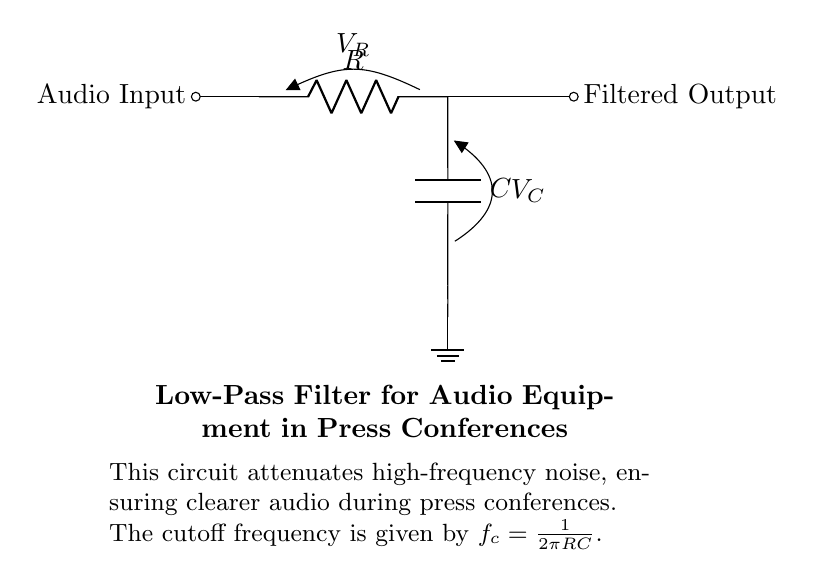What components are in the circuit? The circuit contains a resistor and a capacitor, which are the fundamental components of a low-pass filter. There is also an audio input and a filtered output indicated in the diagram.
Answer: Resistor and Capacitor What is the function of the resistor in this circuit? The resistor limits the current flow in the circuit, which affects the voltage drop across it and helps determine the overall behavior of the filter. In this configuration, it collaborates with the capacitor to set the cutoff frequency.
Answer: Limit current flow What is the cutoff frequency formula for this low-pass filter? The cutoff frequency of the low-pass filter is defined by the relationship between the resistor (R) and capacitor (C) values. According to the circuit diagram, the formula is given as f_c = 1/(2πRC).
Answer: f_c = 1/(2πRC) How does increasing the capacitance affect the cutoff frequency? Increasing capacitance (C) will decrease the cutoff frequency (f_c), as per the formula. A lower cutoff frequency means that the filter allows fewer high-frequency signals to pass, which is desirable for clearer audio.
Answer: Decreases cutoff frequency What happens to high-frequency noise when using this filter? The circuit is designed to attenuate or reduce high-frequency noise, which ensures that only low frequencies are allowed through to the output. This results in clearer audio during press conferences.
Answer: Attenuates high-frequency noise What is the relationship between resistor value and audio output quality? A higher resistor value increases the time constant of the RC circuit, which can lead to slower responses and may result in a less sharp cutoff at the desired frequency. This can adversely affect audio clarity, particularly with transients.
Answer: Affects audio clarity What does the symbol at the bottom left represent? The symbol at the bottom left represents the ground in the circuit, which is a reference point for the voltages in the system and provides a common return path for current.
Answer: Ground 